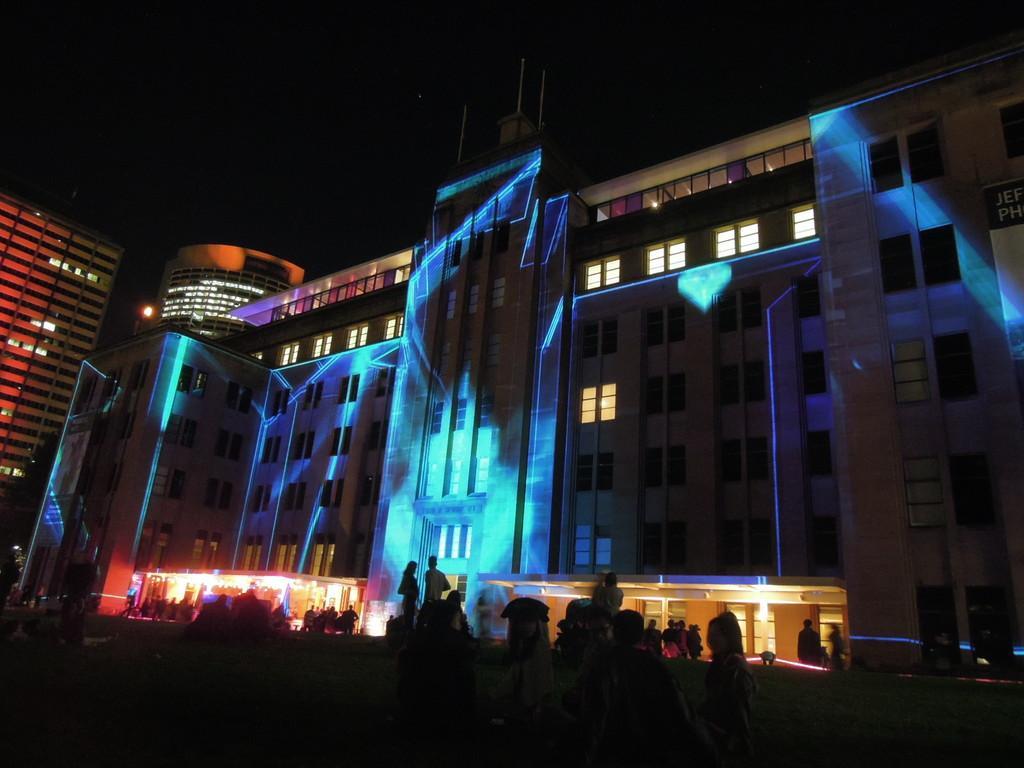Could you give a brief overview of what you see in this image? In the middle of this image, there are buildings which are having lights. At the bottom of this image, there are persons and plants on the ground. And the background is dark in color. 